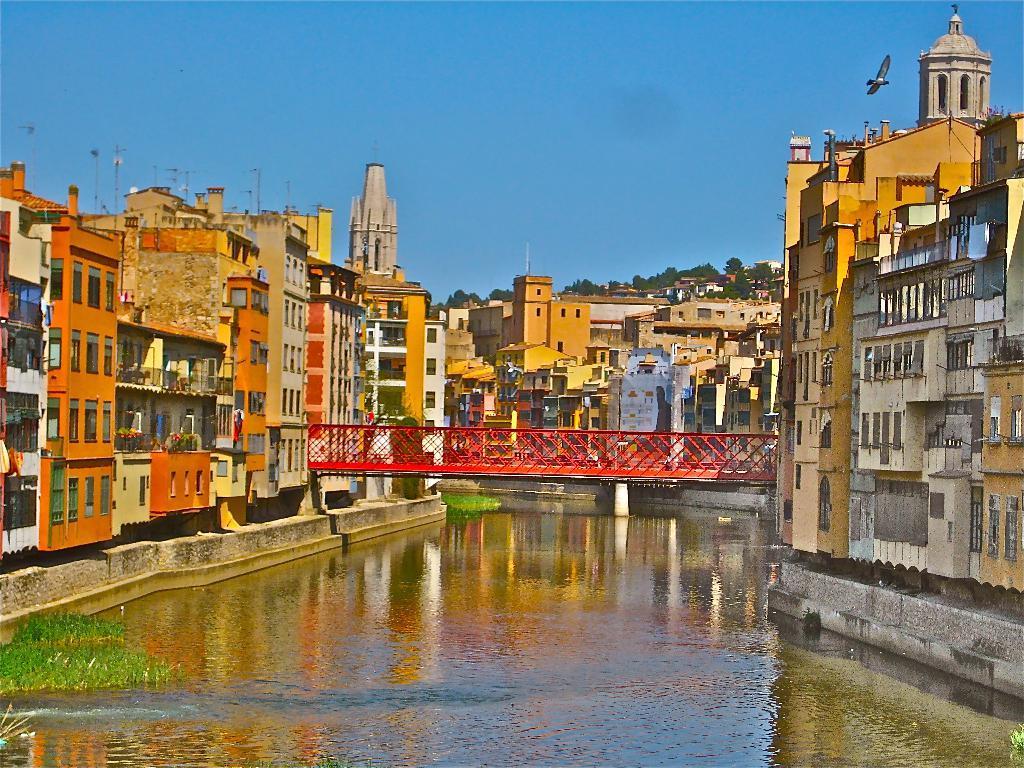Could you give a brief overview of what you see in this image? In this image we can see buildings, there are some plants on the water, there are poles, trees, there is a bird flying in the sky, also we can see trees. 